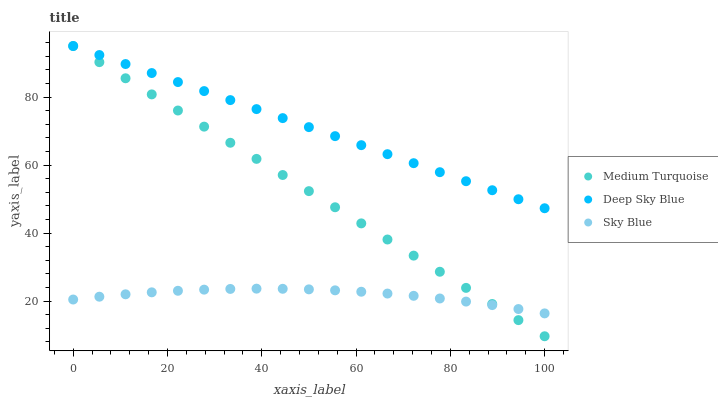Does Sky Blue have the minimum area under the curve?
Answer yes or no. Yes. Does Deep Sky Blue have the maximum area under the curve?
Answer yes or no. Yes. Does Medium Turquoise have the minimum area under the curve?
Answer yes or no. No. Does Medium Turquoise have the maximum area under the curve?
Answer yes or no. No. Is Deep Sky Blue the smoothest?
Answer yes or no. Yes. Is Sky Blue the roughest?
Answer yes or no. Yes. Is Medium Turquoise the smoothest?
Answer yes or no. No. Is Medium Turquoise the roughest?
Answer yes or no. No. Does Medium Turquoise have the lowest value?
Answer yes or no. Yes. Does Deep Sky Blue have the lowest value?
Answer yes or no. No. Does Medium Turquoise have the highest value?
Answer yes or no. Yes. Is Sky Blue less than Deep Sky Blue?
Answer yes or no. Yes. Is Deep Sky Blue greater than Sky Blue?
Answer yes or no. Yes. Does Medium Turquoise intersect Deep Sky Blue?
Answer yes or no. Yes. Is Medium Turquoise less than Deep Sky Blue?
Answer yes or no. No. Is Medium Turquoise greater than Deep Sky Blue?
Answer yes or no. No. Does Sky Blue intersect Deep Sky Blue?
Answer yes or no. No. 